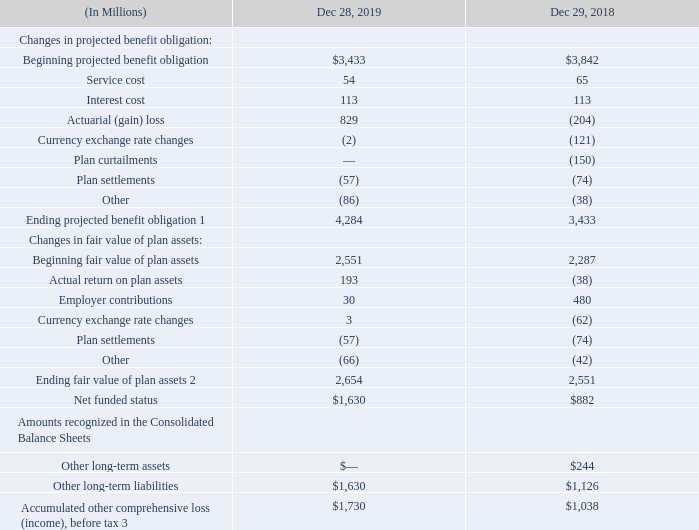BENEFIT OBLIGATION AND PLAN ASSETS FOR PENSION BENEFIT PLANS
The vested benefit obligation for a defined-benefit pension plan is the actuarial present value of the vested benefits to which the employee is currently entitled based on the employee’s expected date of separation or retirement.
1 The projected benefit obligation was approximately 35% in the U.S. and 65% outside of the U.S. as of December 28, 2019 and December 29, 2018.
2 The fair value of plan assets was approximately 55% in the U.S. and 45% outside of the U.S. as of December 28, 2019 and December 29, 2018.
3 The accumulated other comprehensive loss (income), before tax, was approximately 35% in the U.S. and 65% outside of the U.S. as of December 28, 2019 and December 29, 2018.
Changes in actuarial gains and losses in the projected benefit obligation are generally driven by discount rate movement. We use the corridor approach to amortize actuarial gains and losses. Under this approach, net actuarial gains or losses in excess of 10% of the larger of the projected benefit obligation or the fair value of plan assets are amortized on a straight-line basis.
What is the main driver of changes in actuarial gains and losses in the projected benefit obligation? Discount rate movement. What approach was used to amortize actuarial gains and loses? The corridor approach. What is the  Beginning projected benefit obligation for Dec 28, 2019?
Answer scale should be: million. $3,433. How much is the ending projected benefit obligation outside of the US in 2018?
Answer scale should be: million. 65% * 3,433 
Answer: 2231.45. How much is the ending fair value of plan assets in the US in 2019?
Answer scale should be: million. 55% * 2,654 
Answer: 1459.7. How much is the percentage change of the Net funded status from 2018 to 2019?
Answer scale should be: percent. (1,630 - 882) / 882 
Answer: 84.81. 